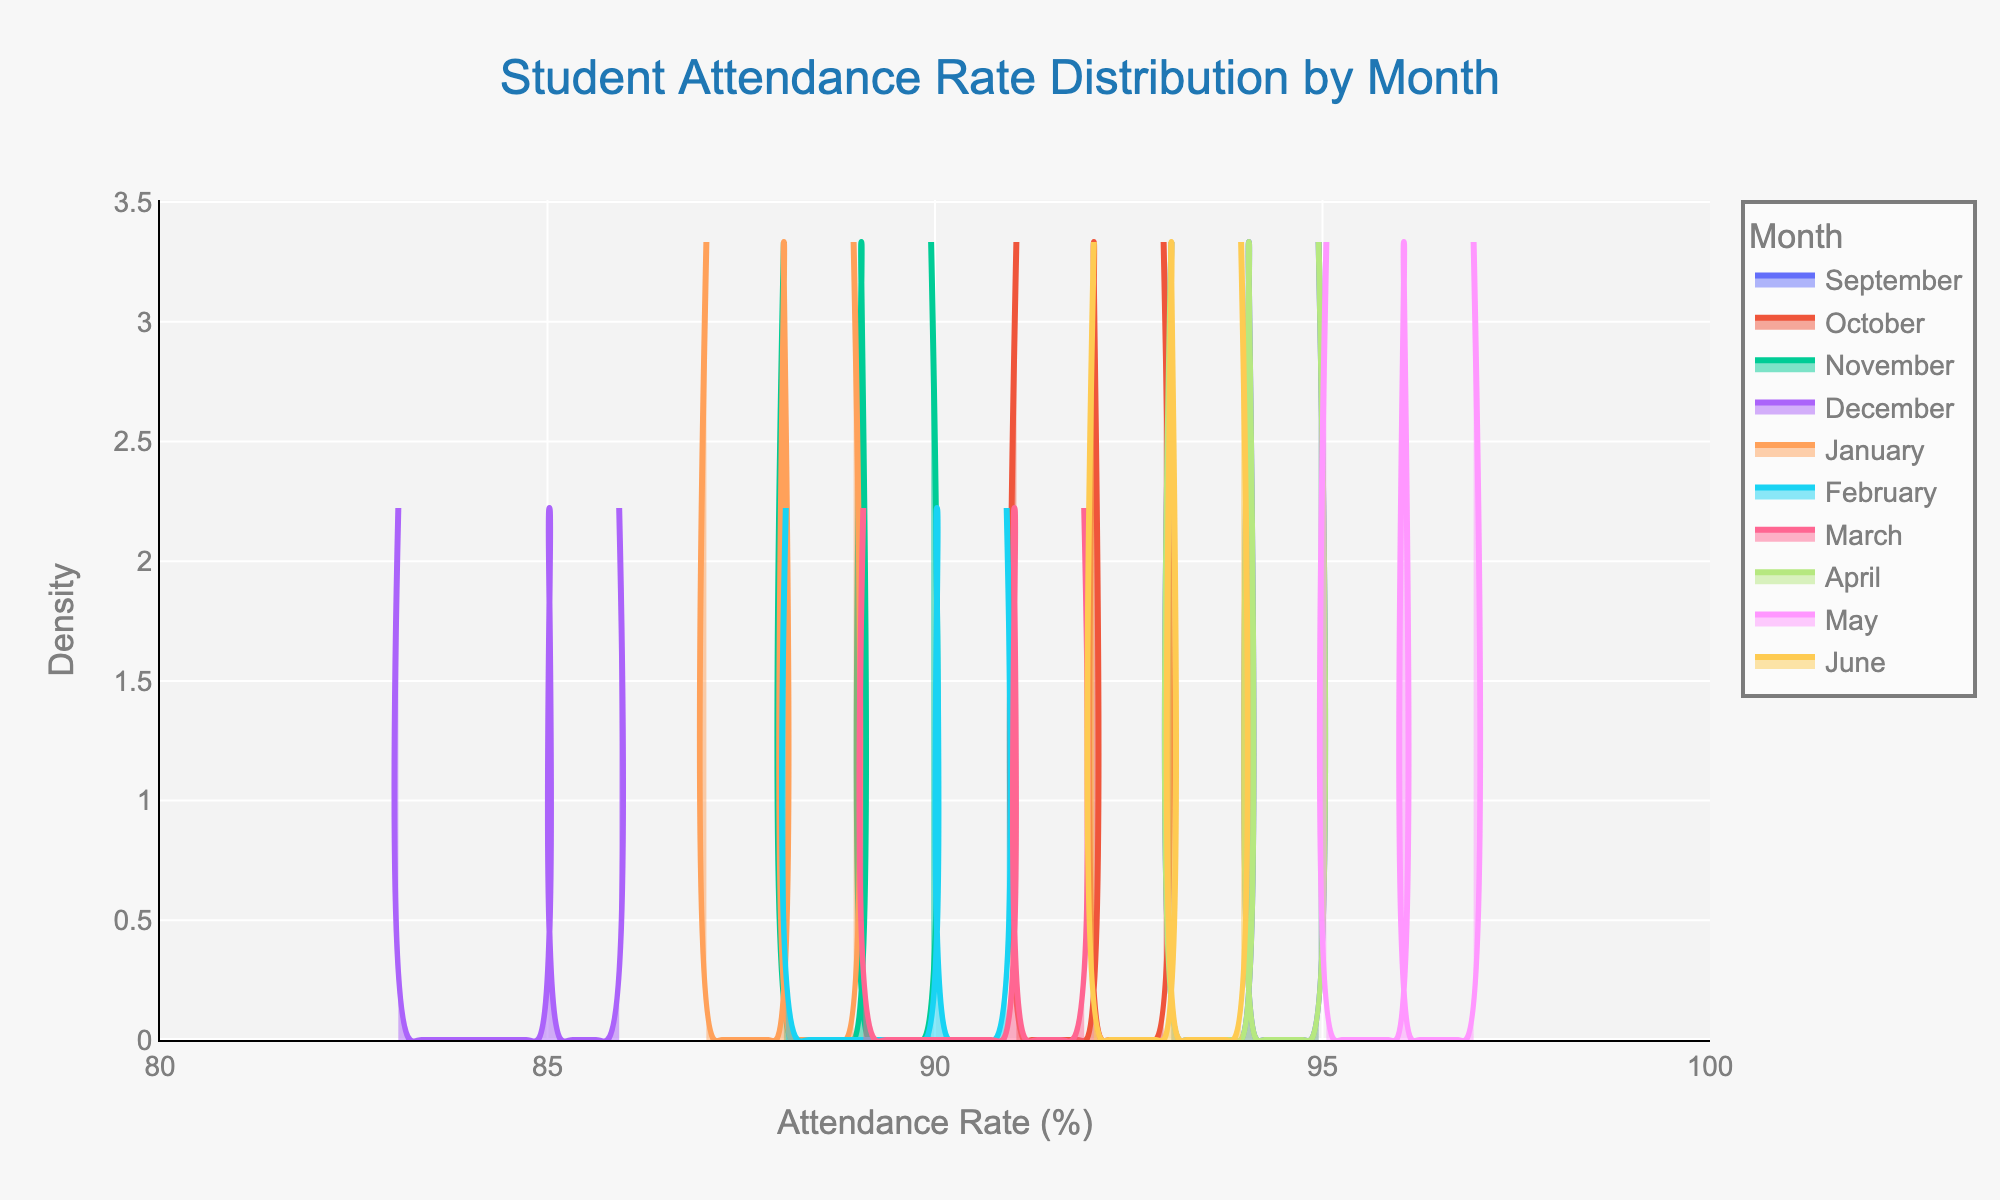What is the title of the plot? The title is usually located at the top of the plot and provides a summary of what the figure represents. In this case, it reads "Student Attendance Rate Distribution by Month".
Answer: Student Attendance Rate Distribution by Month Which month has the highest attendance rate density peak? To identify this, look at the peaks of each month's density plot and compare. The month with the highest peak density represents the month where attendance rates were more concentrated around a particular value.
Answer: May How many months are represented in the plot? For this, count the number of unique traces or colors in the legend that represents different months. There are twelve months in a year, but only some might be included based on the given data.
Answer: 10 What is the general range of the attendance rates? Look at the x-axis labels to determine the start and end points. This will provide the overall range of attendance rates shown in the plot.
Answer: 80% to 100% Which month has the lowest attendance rate density peak? Similar to identifying the highest, find the month whose density distribution has the smallest peak. This month marks lower concentration around specific attendance rates.
Answer: December In which month is the attendance rate distribution most spread out? A more spread out (flatter) curve indicates more variability in attendance rates. Identify which curve is the widest horizontally across the plot.
Answer: December Are any months' attendance rates more centered around 95%? Look at the curves and see which ones have their peaks or are highest around the 95% attendance mark. This indicates a high concentration of students having this attendance rate.
Answer: September, May, June Approximately what attendance rate has the highest density in May? Focus on the peak of the density plot for May and read the corresponding x-axis value.
Answer: 95% 